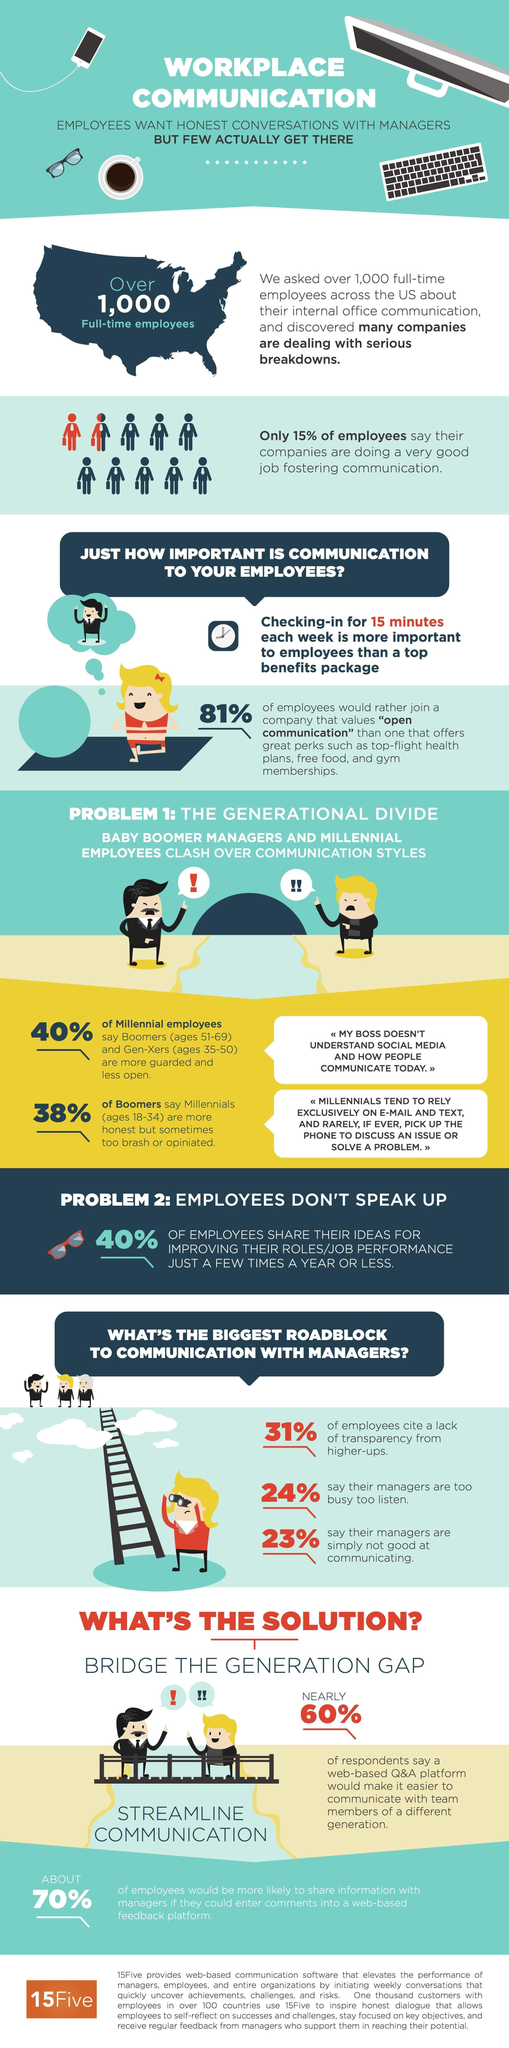What percentage of employees say their managers are too busy to listen?
Answer the question with a short phrase. 24% What percentage of employees say that their companies are doing a very good job fostering communication? 15% What percentage of employees cite a lack of transparency from higher-ups? 31% 